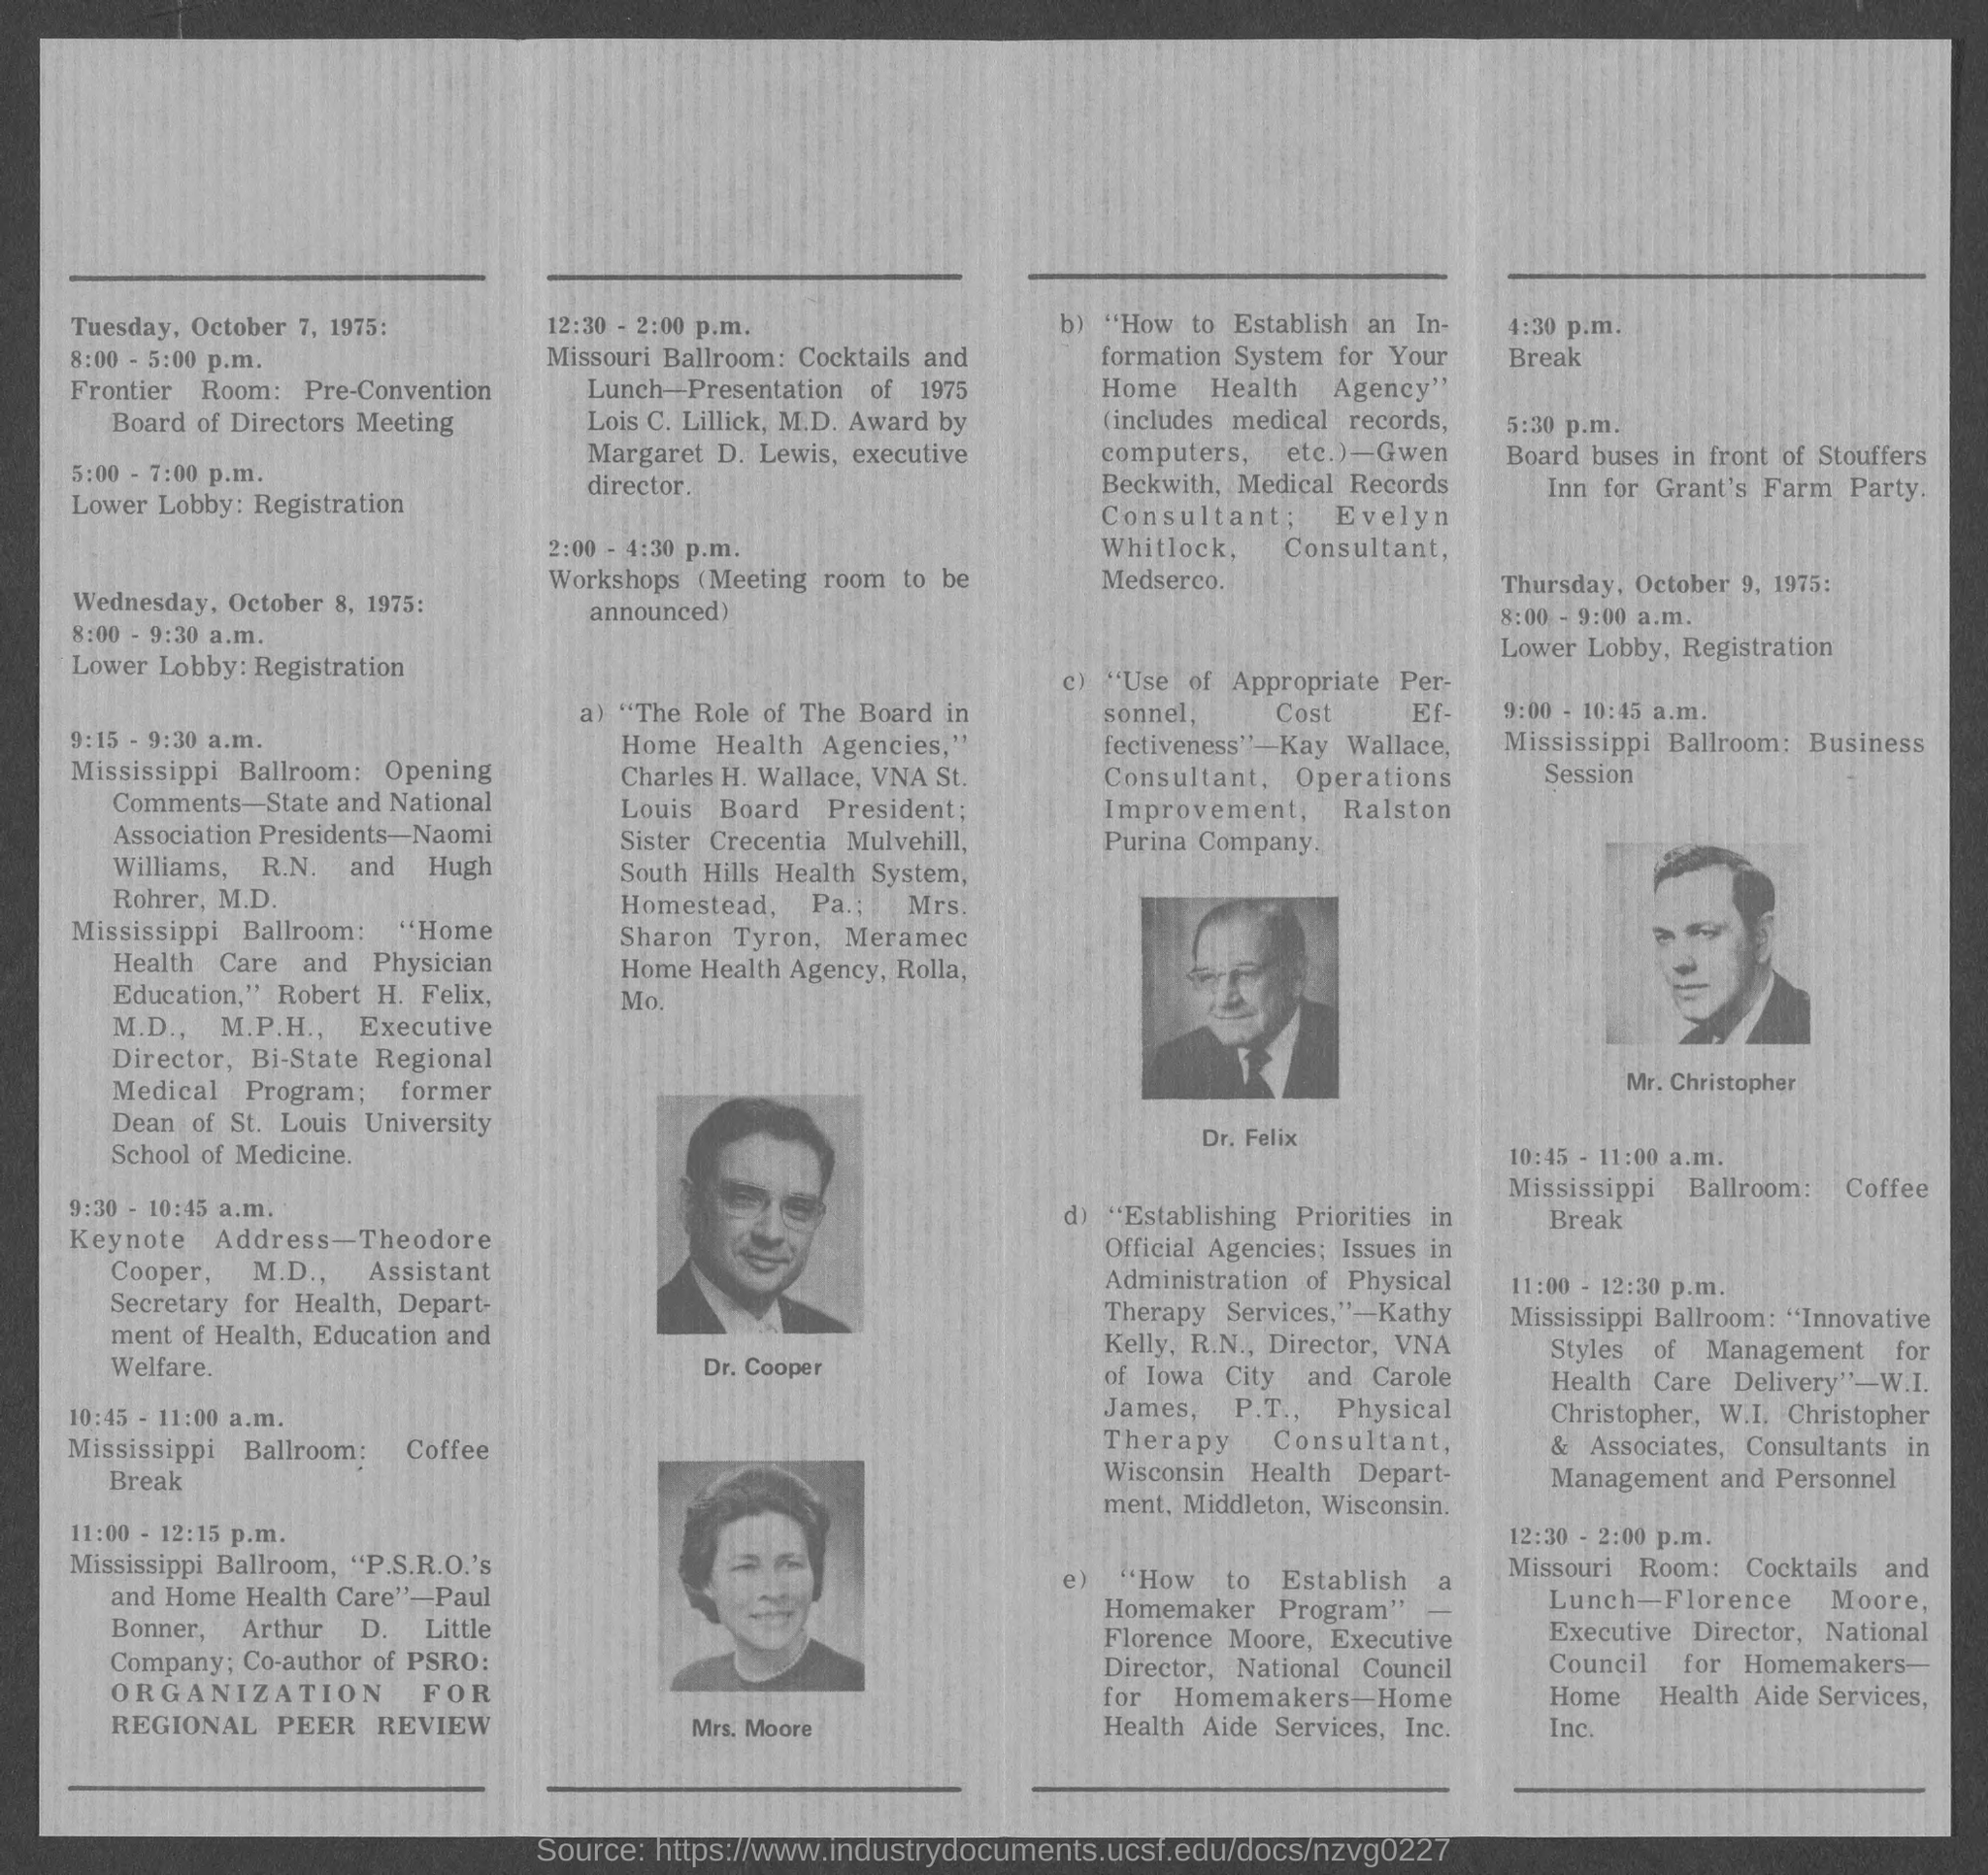Highlight a few significant elements in this photo. The topic of Kay Wallace is the use of appropriate personnel and cost effectiveness, as demonstrated by her expertise in the field. Theodore Cooper, M.D., is giving the Keynote address from 9:30 - 10:45 a.m. I, [Name], declare that on Tuesday, October 7, 1975, the meeting will take place in the Frontier Room. 